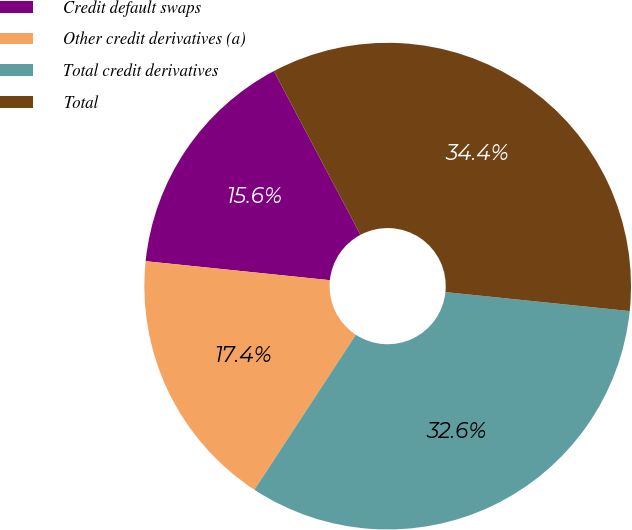Convert chart to OTSL. <chart><loc_0><loc_0><loc_500><loc_500><pie_chart><fcel>Credit default swaps<fcel>Other credit derivatives (a)<fcel>Total credit derivatives<fcel>Total<nl><fcel>15.62%<fcel>17.41%<fcel>32.59%<fcel>34.38%<nl></chart> 